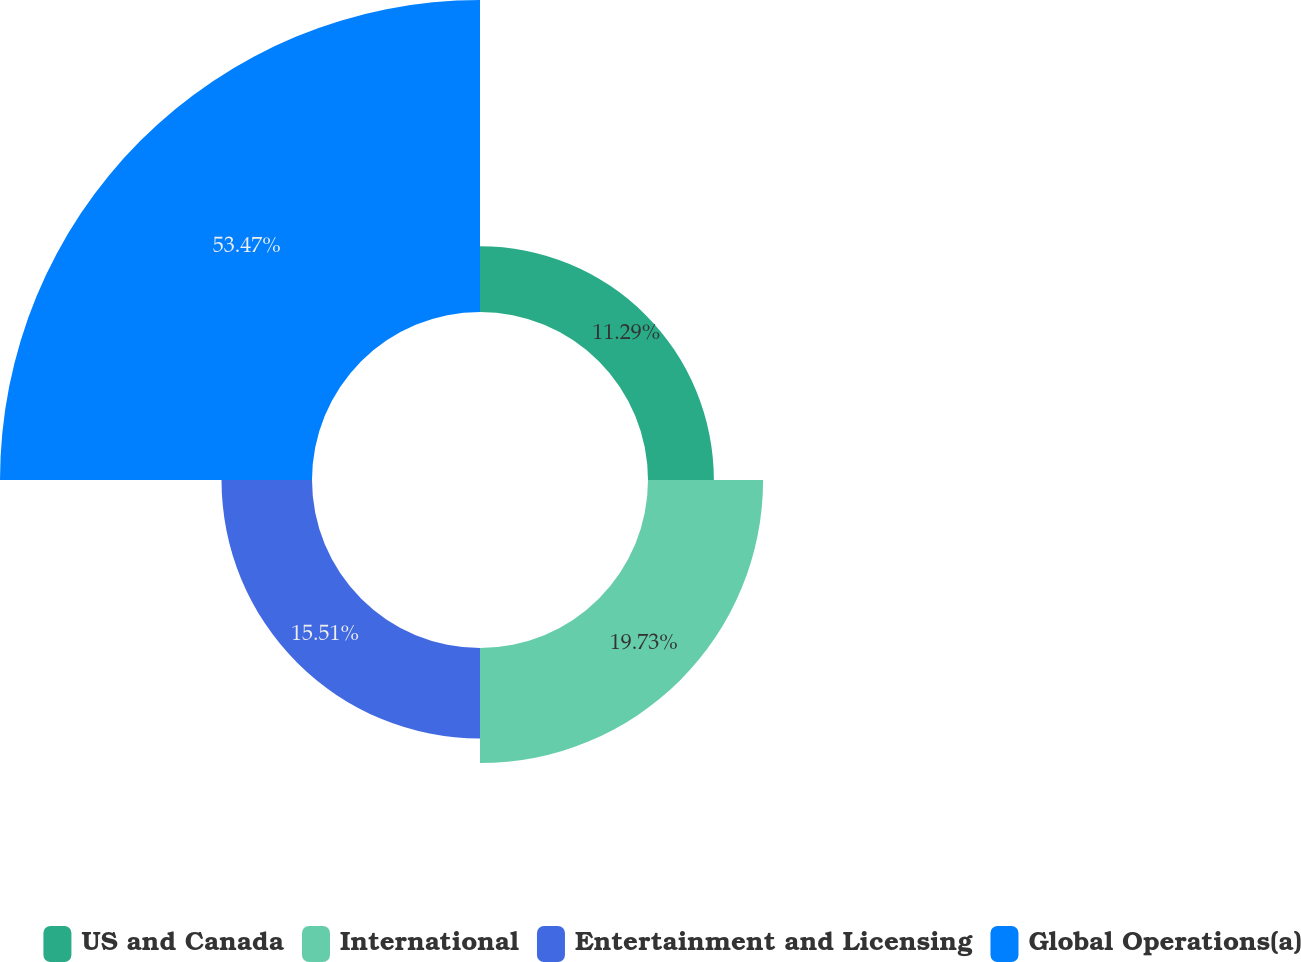Convert chart. <chart><loc_0><loc_0><loc_500><loc_500><pie_chart><fcel>US and Canada<fcel>International<fcel>Entertainment and Licensing<fcel>Global Operations(a)<nl><fcel>11.29%<fcel>19.73%<fcel>15.51%<fcel>53.48%<nl></chart> 